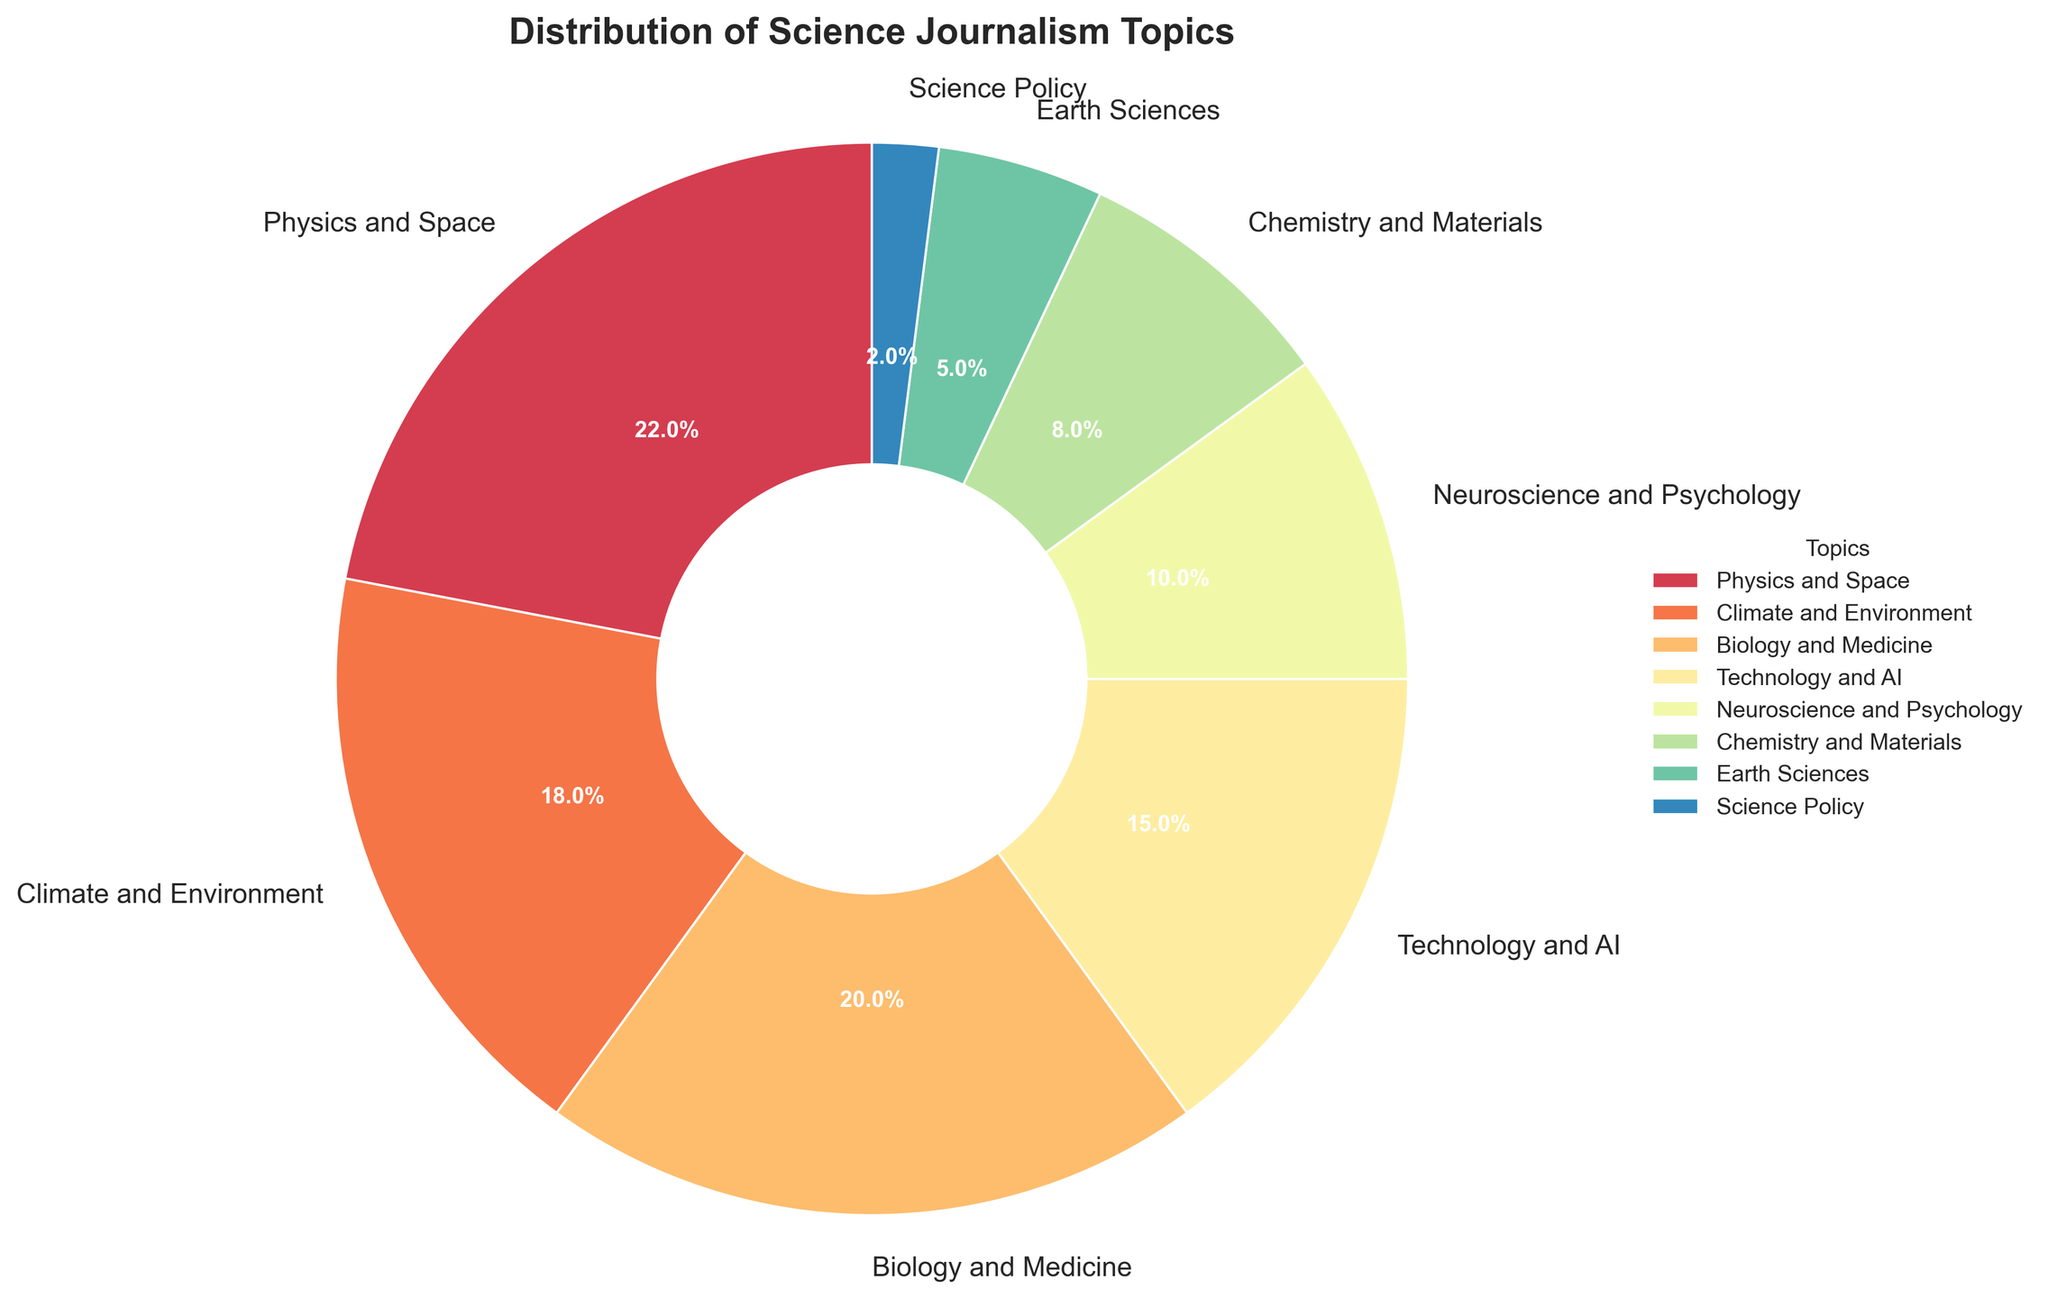Which topic has the largest percentage in the distribution? The topic with the largest slice in the pie chart, labeled with the highest percentage, is "Physics and Space" with 22%.
Answer: Physics and Space Which topic has the smallest representation in the distribution? The smallest slice in the pie chart is labeled "Science Policy" with 2%.
Answer: Science Policy What is the combined percentage of "Biology and Medicine" and "Technology and AI"? "Biology and Medicine" is 20% and "Technology and AI" is 15%. Adding these together: 20% + 15% = 35%.
Answer: 35% How does the percentage of "Climate and Environment" compare to "Neuroscience and Psychology"? "Climate and Environment" is 18%, while "Neuroscience and Psychology" is 10%. 18% is greater than 10%.
Answer: Climate and Environment has a greater percentage What percentage of the pie chart is covered by topics outside the "Physics and Space", "Biology and Medicine", and "Climate and Environment"? First, find the combined percentage of the three topics: 22% + 20% + 18% = 60%. Subtract this from 100% to find the remaining percentage: 100% - 60% = 40%.
Answer: 40% Which topics cumulatively make up exactly half of the distribution? Adding "Physics and Space" (22%) and "Biology and Medicine" (20%) makes 42%. Adding "Climate and Environment" (18%) gets a total of 60%, so we try smaller combinations. "Physics and Space" (22%) + "Technology and AI" (15%) + "Neuroscience and Psychology" (10%) = 47%. Adding "Chemistry and Materials" (8%) makes 55%. Trying "Biology and Medicine" (20%) + "Technology and AI" (15%) + "Neuroscience and Psychology" (10%) + "Earth Sciences" (5%) = 50%. Therefore, combined values are "Biology and Medicine", "Technology and AI", "Neuroscience and Psychology", and "Earth Sciences".
Answer: Biology and Medicine, Technology and AI, Neuroscience and Psychology, and Earth Sciences What is the average percentage of "Earth Sciences" and "Science Policy"? "Earth Sciences" is 5% and "Science Policy" is 2%. Add these percentages and then divide by 2 to find the average: (5% + 2%) / 2 = 3.5%.
Answer: 3.5% Which two topics are closest in terms of their percentage values? "Neuroscience and Psychology" is 10%, while "Chemistry and Materials" is 8%. The difference between them is 10% - 8% = 2%. No other topics have a smaller difference, so these two are the closest.
Answer: Neuroscience and Psychology, and Chemistry and Materials How much larger is the "Physics and Space" percentage compared to "Earth Sciences"? "Physics and Space" is 22% and "Earth Sciences" is 5%. Subtract the "Earth Sciences" percentage from "Physics and Space": 22% - 5% = 17%.
Answer: 17% 